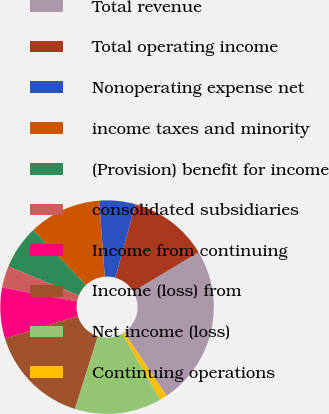Convert chart. <chart><loc_0><loc_0><loc_500><loc_500><pie_chart><fcel>Total revenue<fcel>Total operating income<fcel>Nonoperating expense net<fcel>income taxes and minority<fcel>(Provision) benefit for income<fcel>consolidated subsidiaries<fcel>Income from continuing<fcel>Income (loss) from<fcel>Net income (loss)<fcel>Continuing operations<nl><fcel>24.18%<fcel>12.09%<fcel>5.49%<fcel>10.99%<fcel>6.59%<fcel>3.3%<fcel>7.69%<fcel>15.38%<fcel>13.19%<fcel>1.1%<nl></chart> 